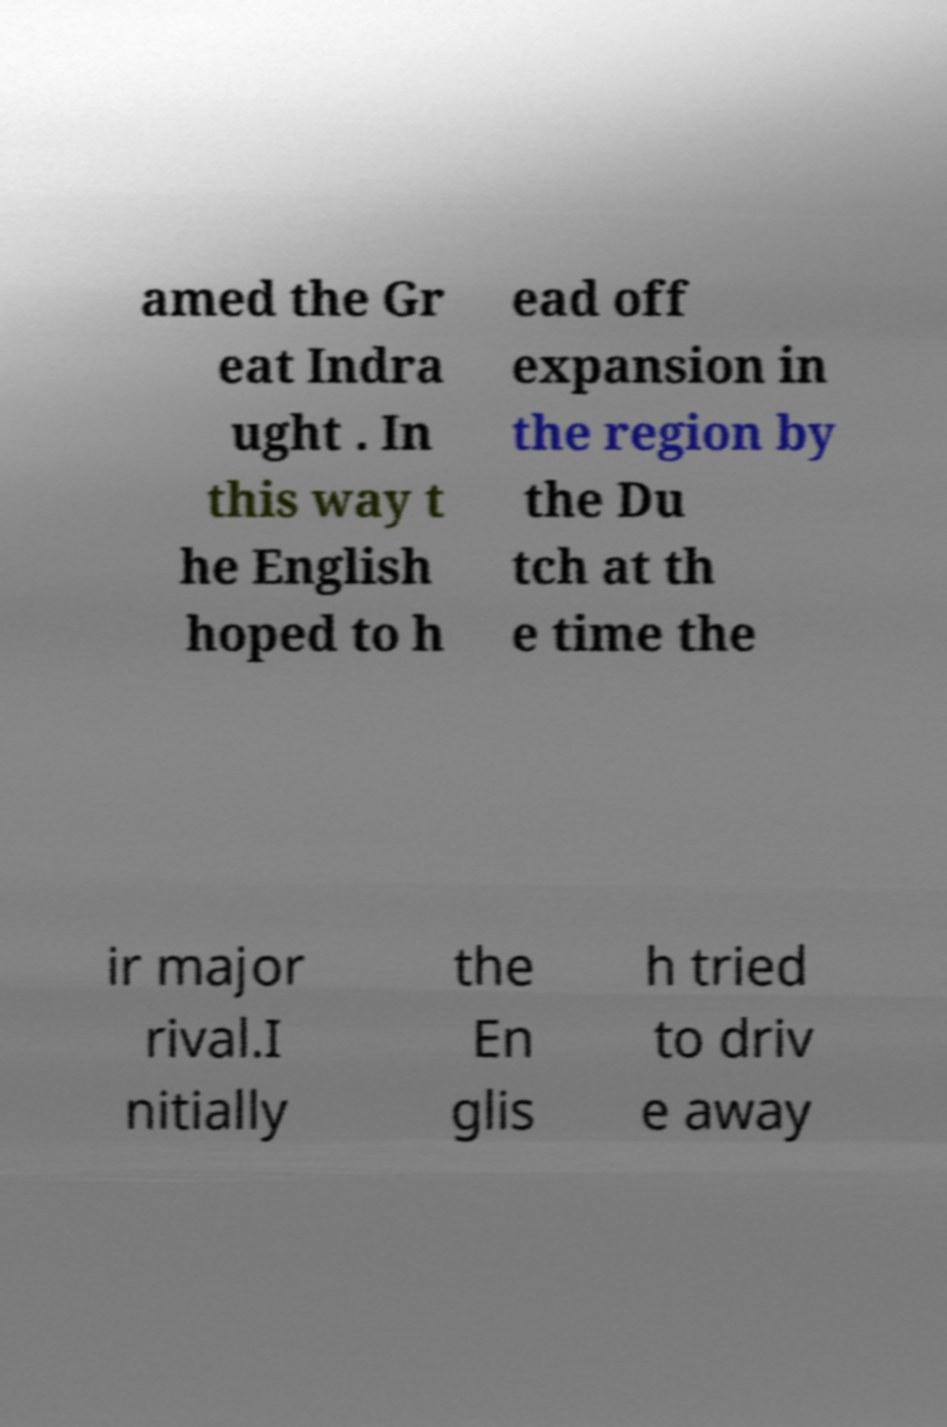Can you read and provide the text displayed in the image?This photo seems to have some interesting text. Can you extract and type it out for me? amed the Gr eat Indra ught . In this way t he English hoped to h ead off expansion in the region by the Du tch at th e time the ir major rival.I nitially the En glis h tried to driv e away 